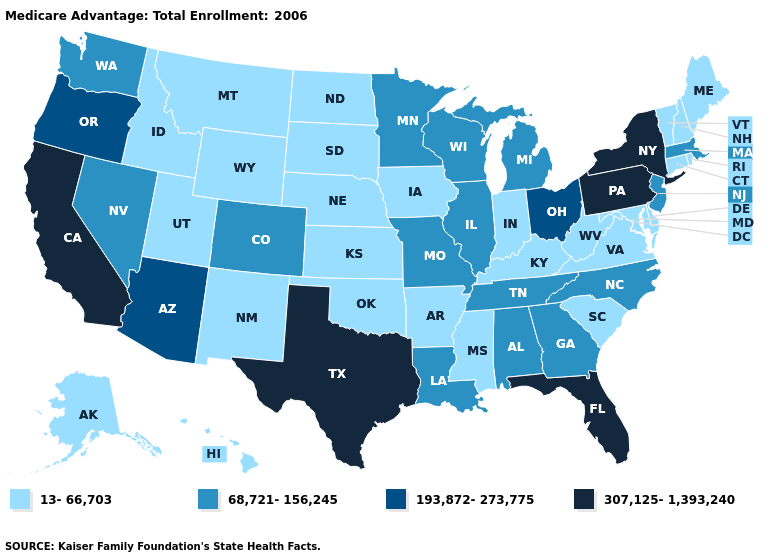Name the states that have a value in the range 13-66,703?
Be succinct. Alaska, Arkansas, Connecticut, Delaware, Hawaii, Iowa, Idaho, Indiana, Kansas, Kentucky, Maryland, Maine, Mississippi, Montana, North Dakota, Nebraska, New Hampshire, New Mexico, Oklahoma, Rhode Island, South Carolina, South Dakota, Utah, Virginia, Vermont, West Virginia, Wyoming. Which states have the lowest value in the MidWest?
Concise answer only. Iowa, Indiana, Kansas, North Dakota, Nebraska, South Dakota. What is the value of Michigan?
Answer briefly. 68,721-156,245. Name the states that have a value in the range 13-66,703?
Concise answer only. Alaska, Arkansas, Connecticut, Delaware, Hawaii, Iowa, Idaho, Indiana, Kansas, Kentucky, Maryland, Maine, Mississippi, Montana, North Dakota, Nebraska, New Hampshire, New Mexico, Oklahoma, Rhode Island, South Carolina, South Dakota, Utah, Virginia, Vermont, West Virginia, Wyoming. What is the value of Alaska?
Answer briefly. 13-66,703. Among the states that border Kansas , does Colorado have the lowest value?
Concise answer only. No. What is the value of West Virginia?
Be succinct. 13-66,703. Which states hav the highest value in the South?
Answer briefly. Florida, Texas. Does Ohio have a higher value than Florida?
Quick response, please. No. Name the states that have a value in the range 193,872-273,775?
Keep it brief. Arizona, Ohio, Oregon. Is the legend a continuous bar?
Keep it brief. No. What is the value of Florida?
Concise answer only. 307,125-1,393,240. Which states have the lowest value in the USA?
Write a very short answer. Alaska, Arkansas, Connecticut, Delaware, Hawaii, Iowa, Idaho, Indiana, Kansas, Kentucky, Maryland, Maine, Mississippi, Montana, North Dakota, Nebraska, New Hampshire, New Mexico, Oklahoma, Rhode Island, South Carolina, South Dakota, Utah, Virginia, Vermont, West Virginia, Wyoming. What is the value of Arkansas?
Answer briefly. 13-66,703. Among the states that border West Virginia , which have the lowest value?
Quick response, please. Kentucky, Maryland, Virginia. 